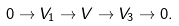Convert formula to latex. <formula><loc_0><loc_0><loc_500><loc_500>0 \rightarrow V _ { 1 } \rightarrow V \rightarrow V _ { 3 } \rightarrow 0 .</formula> 